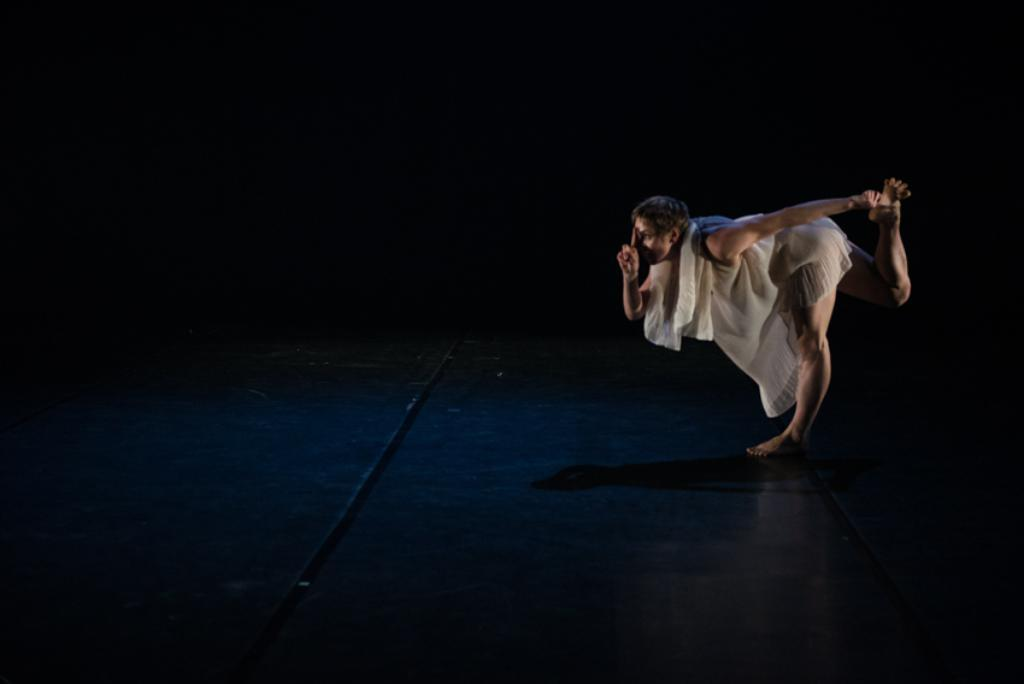Who is the main subject in the image? There is a woman in the image. What is the woman wearing? The woman is wearing a white dress. Where is the woman positioned in the image? The woman is standing in the front of the image. What can be observed about the background of the image? The background of the image is dark. What type of government is depicted in the image? There is no government depicted in the image; it features a woman standing in a dark background. Who is the expert in the image? There is no expert present in the image; it features a woman standing in a dark background. 